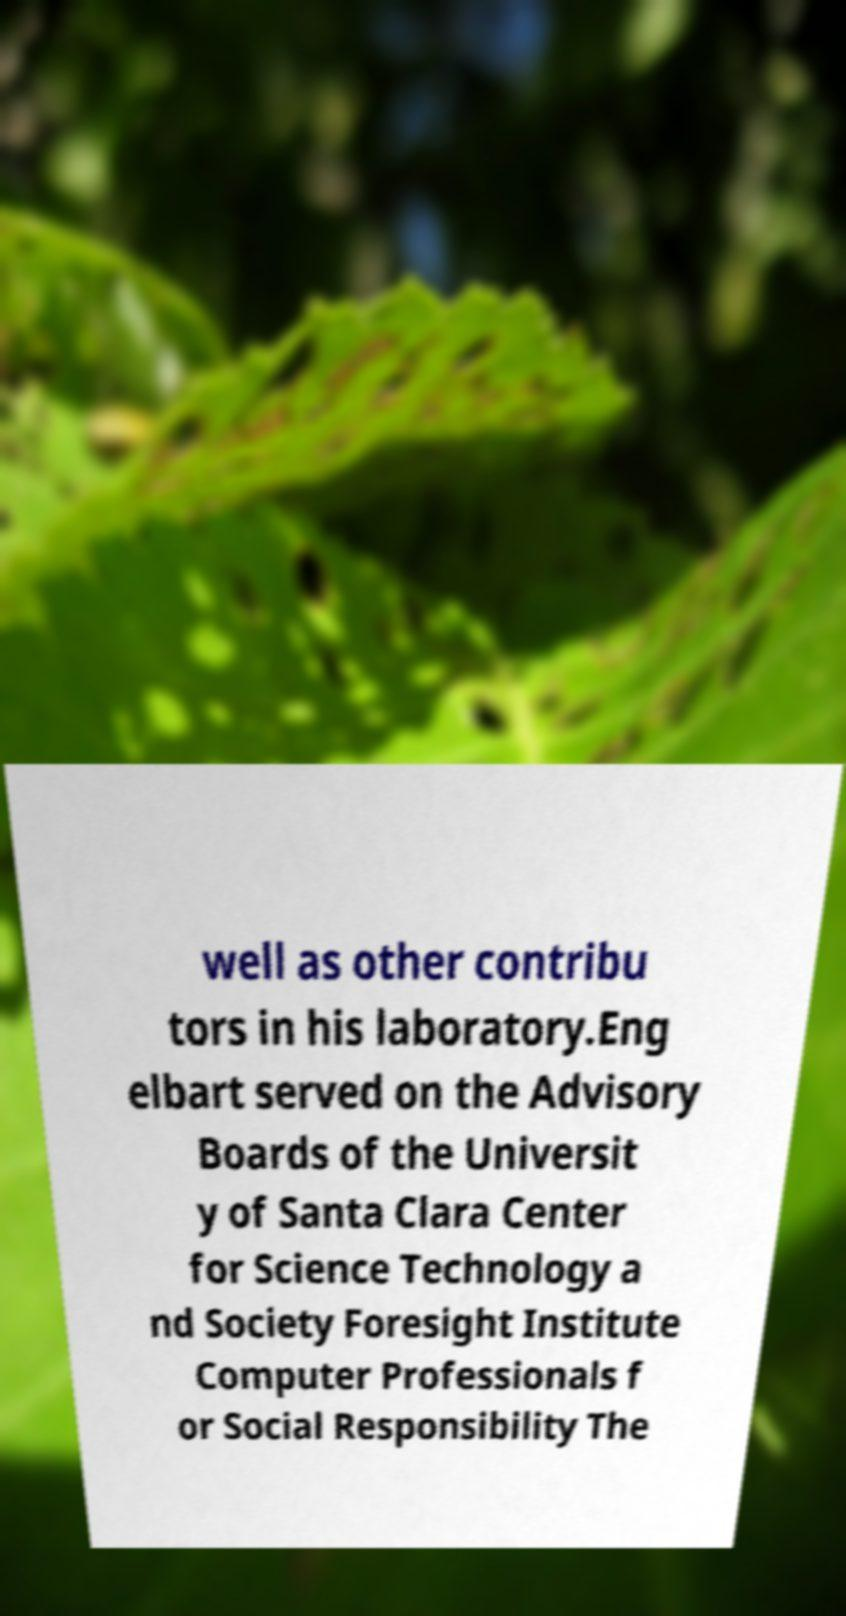Could you extract and type out the text from this image? well as other contribu tors in his laboratory.Eng elbart served on the Advisory Boards of the Universit y of Santa Clara Center for Science Technology a nd Society Foresight Institute Computer Professionals f or Social Responsibility The 